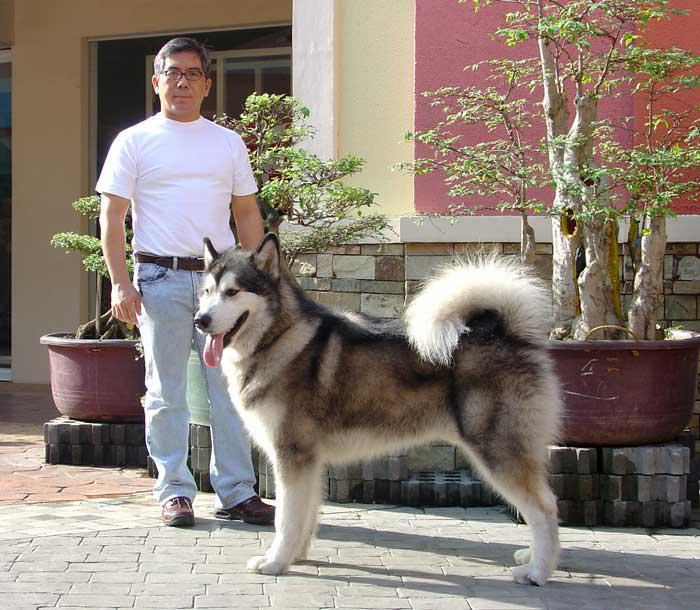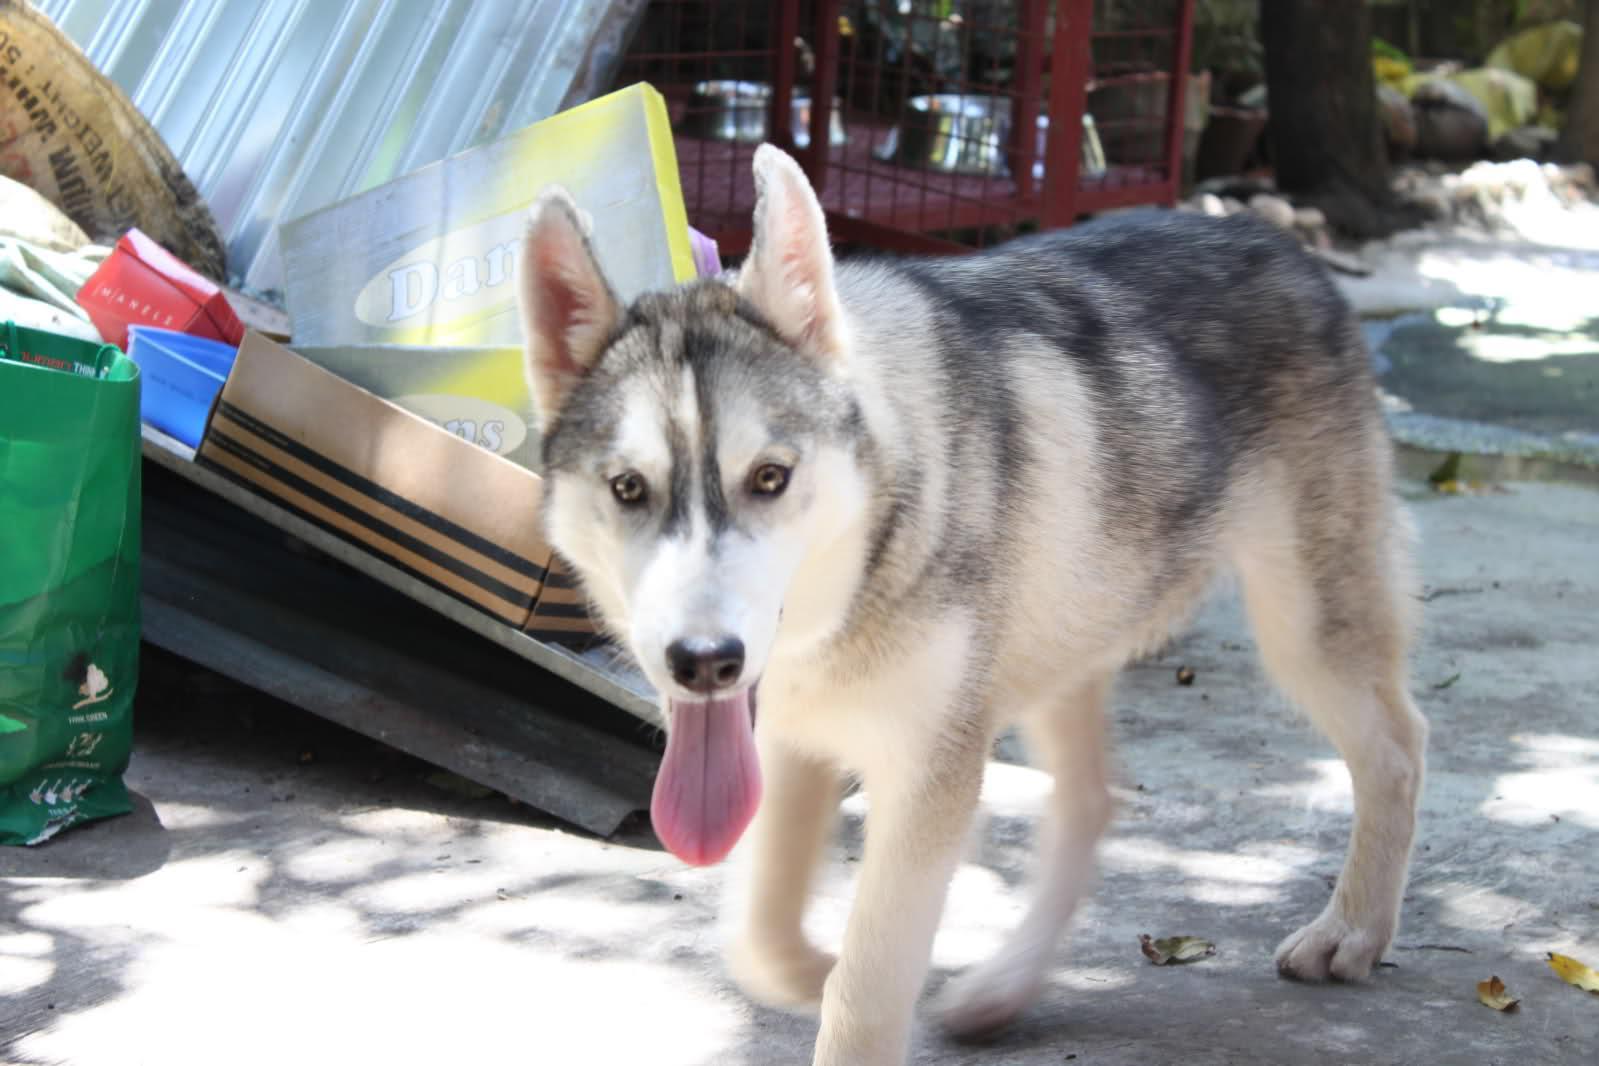The first image is the image on the left, the second image is the image on the right. Assess this claim about the two images: "The combined images include at least two husky dogs, with at least one black-and-white, and one standing with tongue out and a man kneeling behind it.". Correct or not? Answer yes or no. No. The first image is the image on the left, the second image is the image on the right. Evaluate the accuracy of this statement regarding the images: "The right image contains one human interacting with at least one dog.". Is it true? Answer yes or no. No. 